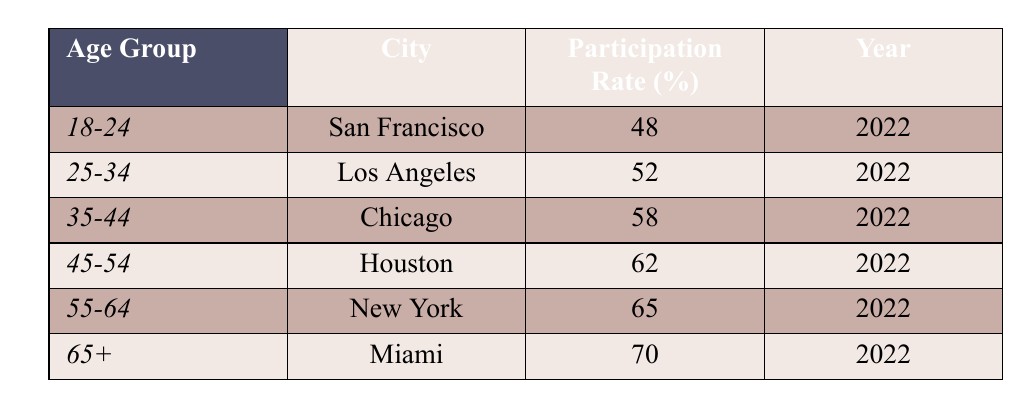What is the participation rate percentage for the age group 65+ in Miami? The table shows that for the age group 65+, the participation rate percentage is specifically listed under Miami. The entry for this group indicates that the rate is 70%.
Answer: 70 Which age group has the highest participation rate percentage and what is that percentage? Looking at the table, the age group with the highest participation rate percentage is 65+, with a rate of 70%.
Answer: 65+ and 70 What is the average participation rate percentage for the age groups 45-54 and 55-64? To find the average participation rate for these two groups, first locate their percentages: 62% for 45-54 and 65% for 55-64. The average is calculated as (62 + 65) / 2, which equals 63.5%.
Answer: 63.5 Is the participation rate for the 18-24 age group higher than 50%? The rate for the 18-24 age group is 48%, which is below 50%. Thus, the answer is no.
Answer: No How much higher is the participation rate percentage for the age group 65+ compared to the 18-24 age group? First, identify the participation rates: 65+ has a rate of 70% and 18-24 has a rate of 48%. The difference is calculated as 70 - 48 = 22%.
Answer: 22% 